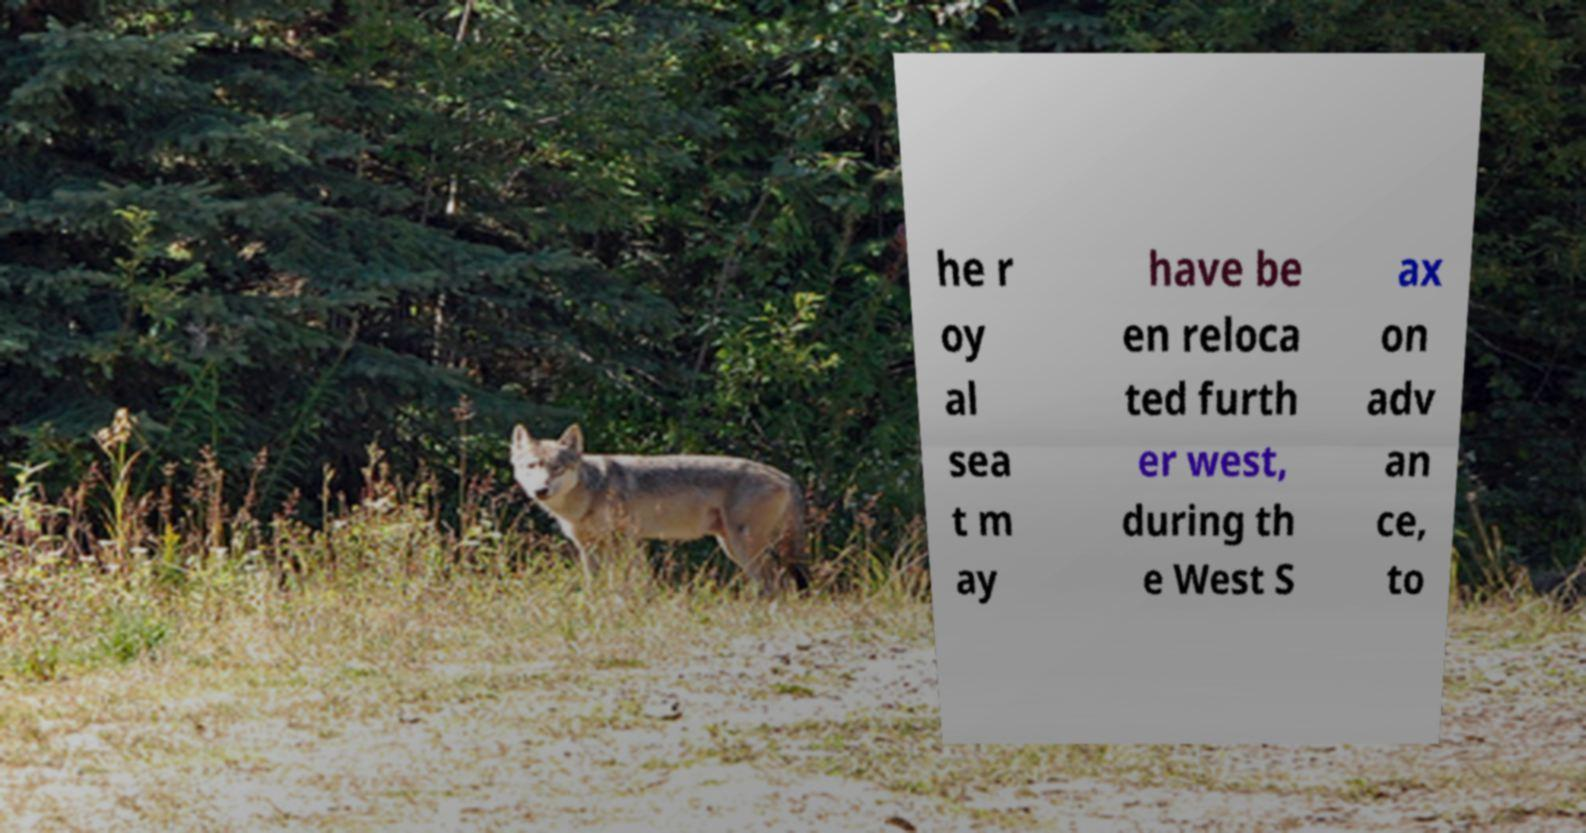Can you read and provide the text displayed in the image?This photo seems to have some interesting text. Can you extract and type it out for me? he r oy al sea t m ay have be en reloca ted furth er west, during th e West S ax on adv an ce, to 